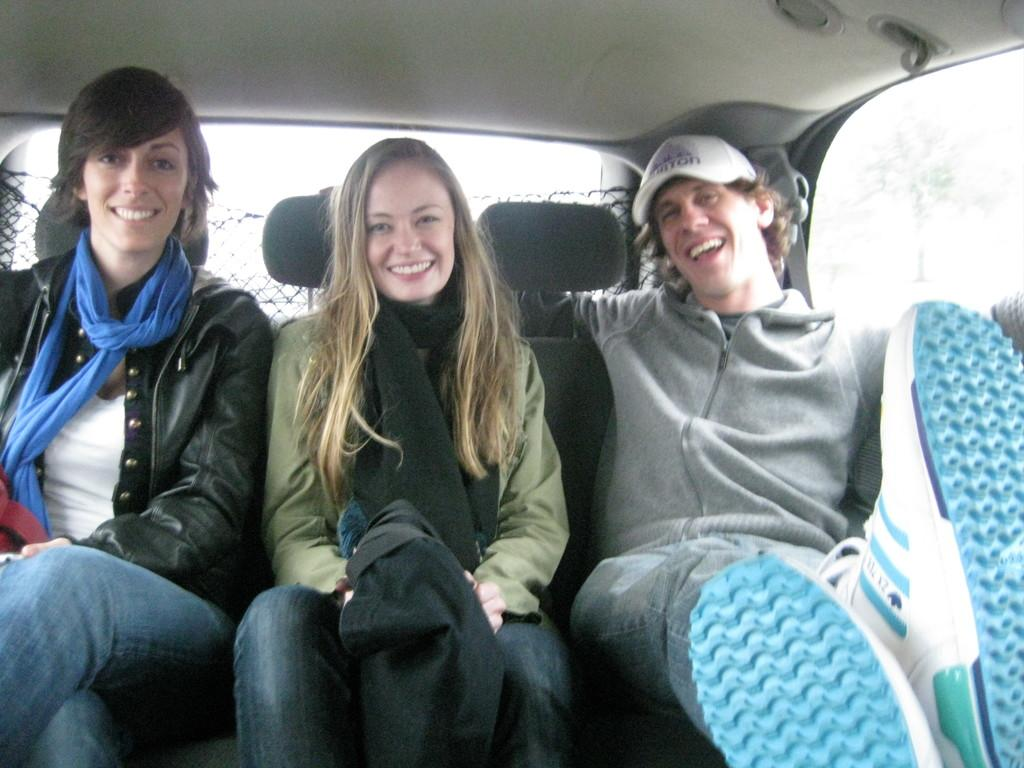How many people are in the image? There are three people in the image. What are the people in the image doing? The three people are sitting in a car. What is the mood of the people in the image? All three people are smiling. Can you describe the appearance of one of the people in the image? One person is wearing a cap. What type of hammer can be seen in the image? There is no hammer present in the image. What time of day is it in the image? The time of day is not mentioned in the image, so it cannot be determined. 